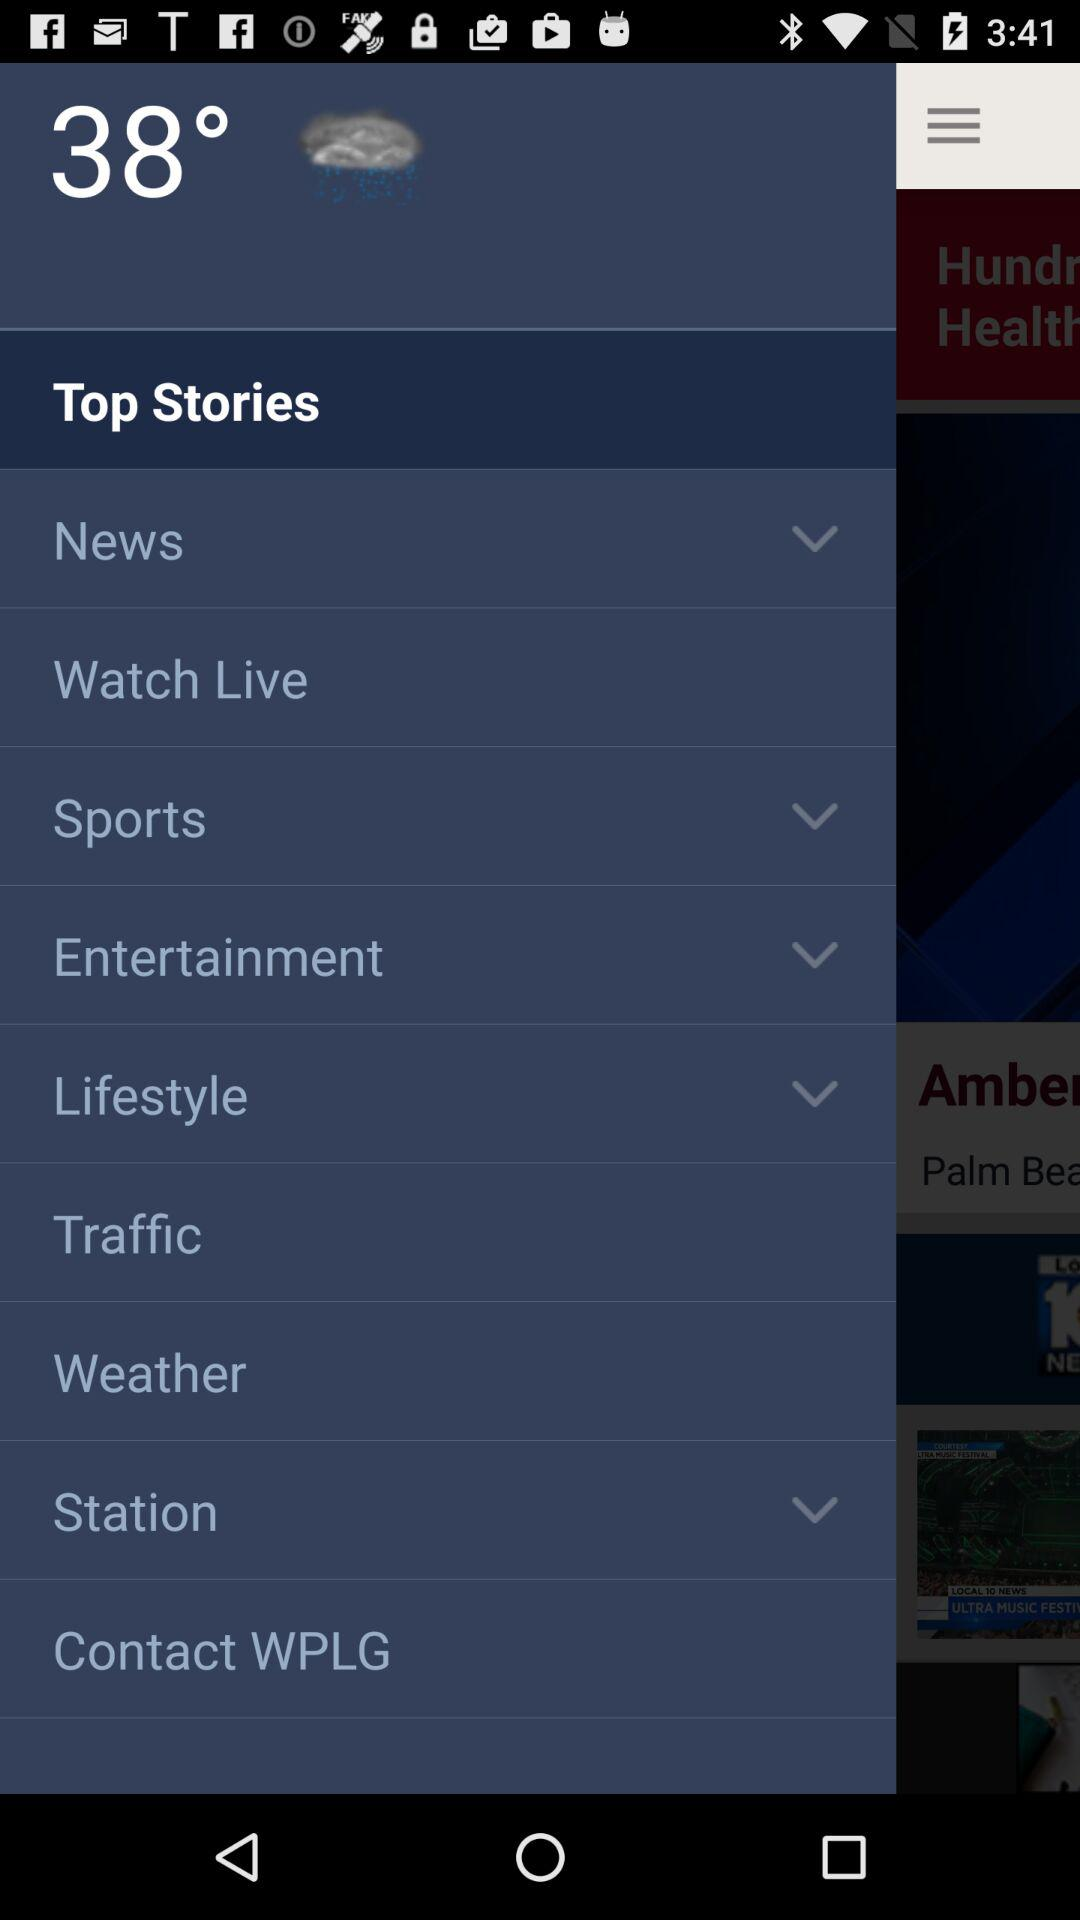What is the temperature? The temperature is 38°. 